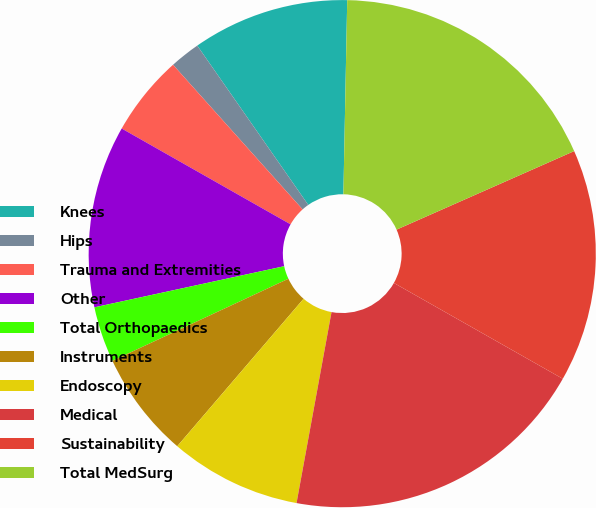Convert chart to OTSL. <chart><loc_0><loc_0><loc_500><loc_500><pie_chart><fcel>Knees<fcel>Hips<fcel>Trauma and Extremities<fcel>Other<fcel>Total Orthopaedics<fcel>Instruments<fcel>Endoscopy<fcel>Medical<fcel>Sustainability<fcel>Total MedSurg<nl><fcel>10.0%<fcel>1.94%<fcel>5.16%<fcel>11.61%<fcel>3.55%<fcel>6.78%<fcel>8.39%<fcel>19.67%<fcel>14.84%<fcel>18.06%<nl></chart> 